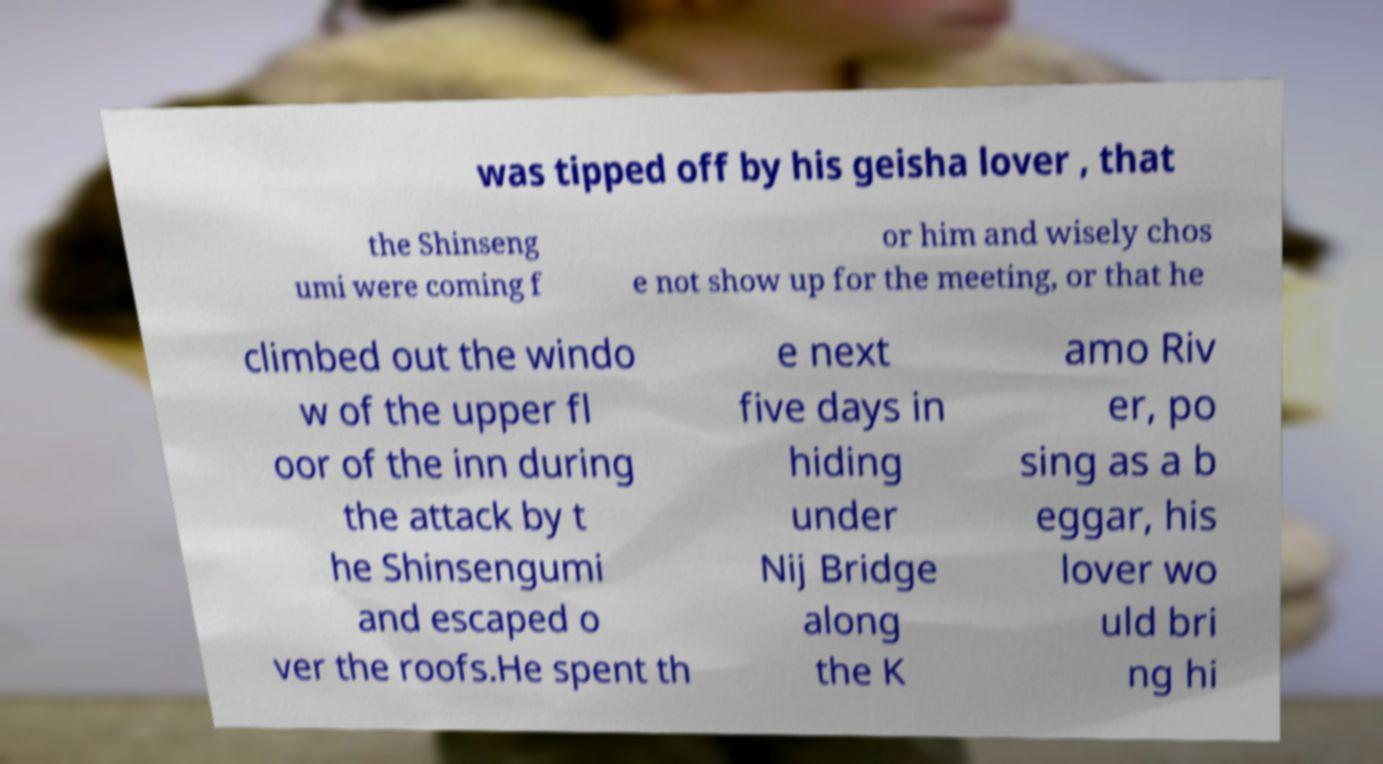Please identify and transcribe the text found in this image. was tipped off by his geisha lover , that the Shinseng umi were coming f or him and wisely chos e not show up for the meeting, or that he climbed out the windo w of the upper fl oor of the inn during the attack by t he Shinsengumi and escaped o ver the roofs.He spent th e next five days in hiding under Nij Bridge along the K amo Riv er, po sing as a b eggar, his lover wo uld bri ng hi 